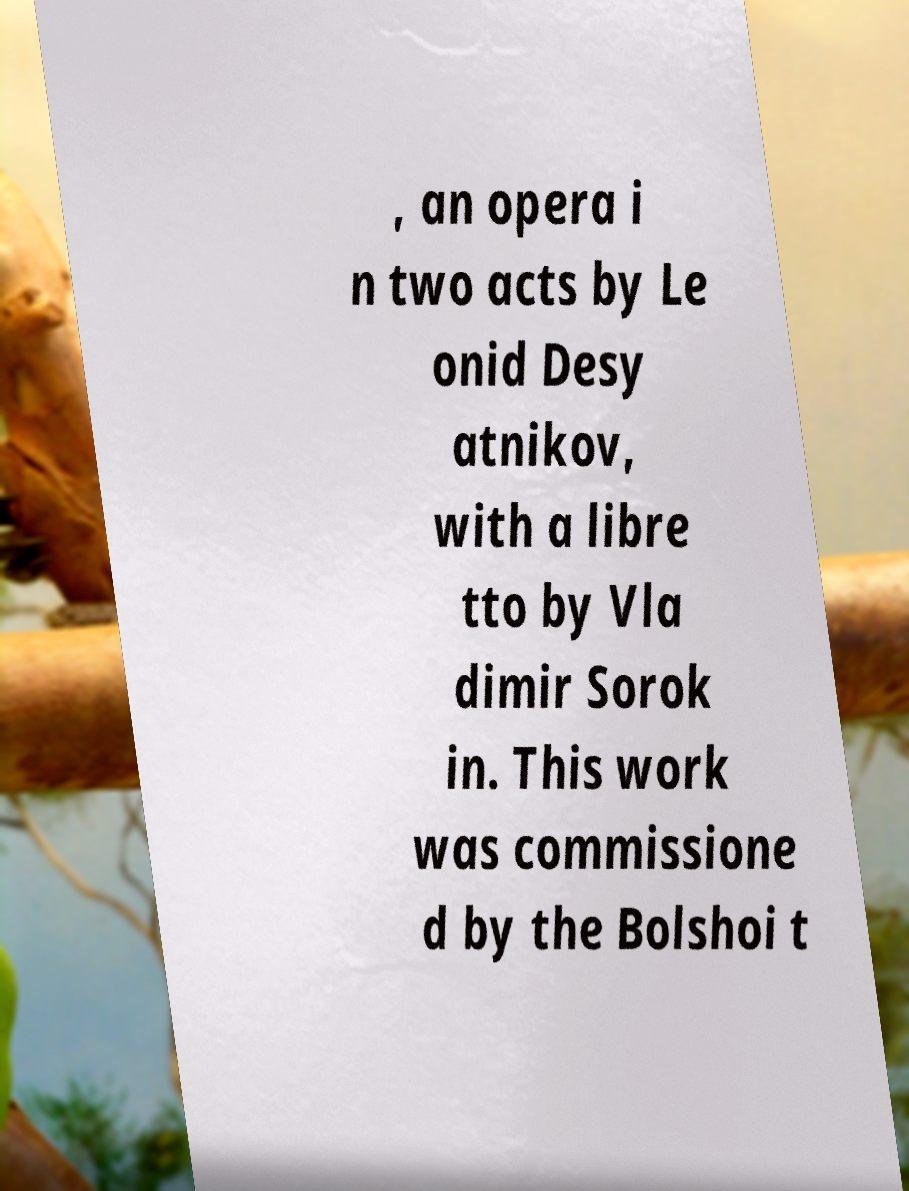Can you accurately transcribe the text from the provided image for me? , an opera i n two acts by Le onid Desy atnikov, with a libre tto by Vla dimir Sorok in. This work was commissione d by the Bolshoi t 